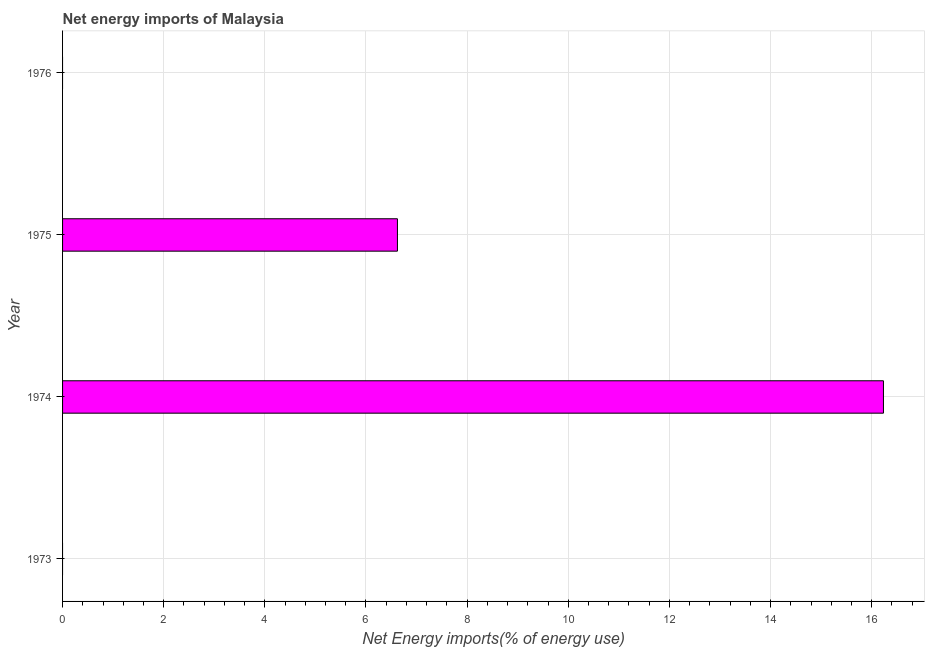What is the title of the graph?
Provide a succinct answer. Net energy imports of Malaysia. What is the label or title of the X-axis?
Your answer should be compact. Net Energy imports(% of energy use). What is the label or title of the Y-axis?
Ensure brevity in your answer.  Year. What is the energy imports in 1975?
Ensure brevity in your answer.  6.62. Across all years, what is the maximum energy imports?
Your answer should be very brief. 16.23. Across all years, what is the minimum energy imports?
Keep it short and to the point. 0. In which year was the energy imports maximum?
Offer a terse response. 1974. What is the sum of the energy imports?
Make the answer very short. 22.85. What is the difference between the energy imports in 1974 and 1975?
Your answer should be compact. 9.61. What is the average energy imports per year?
Your answer should be compact. 5.71. What is the median energy imports?
Offer a terse response. 3.31. In how many years, is the energy imports greater than 9.2 %?
Your answer should be very brief. 1. What is the ratio of the energy imports in 1974 to that in 1975?
Your answer should be very brief. 2.45. Is the energy imports in 1974 less than that in 1975?
Offer a very short reply. No. Is the difference between the energy imports in 1974 and 1975 greater than the difference between any two years?
Your answer should be compact. No. What is the difference between the highest and the lowest energy imports?
Provide a short and direct response. 16.23. How many bars are there?
Your answer should be very brief. 2. How many years are there in the graph?
Offer a very short reply. 4. Are the values on the major ticks of X-axis written in scientific E-notation?
Offer a terse response. No. What is the Net Energy imports(% of energy use) in 1973?
Give a very brief answer. 0. What is the Net Energy imports(% of energy use) in 1974?
Your answer should be very brief. 16.23. What is the Net Energy imports(% of energy use) in 1975?
Offer a terse response. 6.62. What is the Net Energy imports(% of energy use) in 1976?
Offer a very short reply. 0. What is the difference between the Net Energy imports(% of energy use) in 1974 and 1975?
Your response must be concise. 9.61. What is the ratio of the Net Energy imports(% of energy use) in 1974 to that in 1975?
Ensure brevity in your answer.  2.45. 